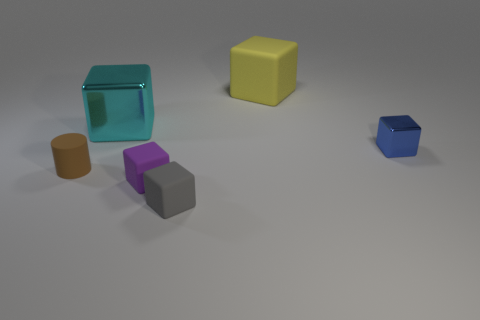Subtract all blue blocks. How many blocks are left? 4 Add 1 large blue shiny spheres. How many objects exist? 7 Subtract 3 cubes. How many cubes are left? 2 Subtract all gray cubes. How many cubes are left? 4 Subtract all blocks. How many objects are left? 1 Subtract all small yellow matte cubes. Subtract all brown cylinders. How many objects are left? 5 Add 6 large cubes. How many large cubes are left? 8 Add 5 tiny purple cubes. How many tiny purple cubes exist? 6 Subtract 1 brown cylinders. How many objects are left? 5 Subtract all yellow blocks. Subtract all yellow cylinders. How many blocks are left? 4 